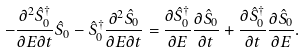Convert formula to latex. <formula><loc_0><loc_0><loc_500><loc_500>- \frac { \partial ^ { 2 } \hat { S } _ { 0 } ^ { \dagger } } { \partial E \partial t } \hat { S } _ { 0 } - \hat { S } _ { 0 } ^ { \dagger } \frac { \partial ^ { 2 } \hat { S } _ { 0 } } { \partial E \partial t } = \frac { \partial \hat { S } _ { 0 } ^ { \dagger } } { \partial E } \frac { \partial \hat { S } _ { 0 } } { \partial t } + \frac { \partial \hat { S } _ { 0 } ^ { \dagger } } { \partial t } \frac { \partial \hat { S } _ { 0 } } { \partial E } .</formula> 